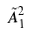<formula> <loc_0><loc_0><loc_500><loc_500>\tilde { A } _ { 1 } ^ { 2 }</formula> 